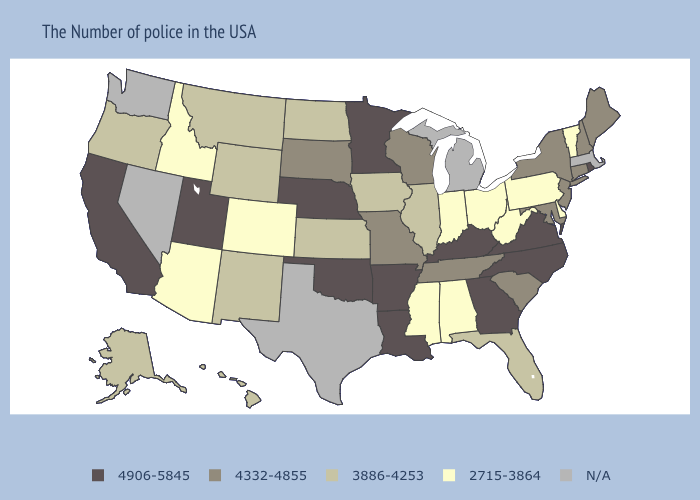Does the map have missing data?
Short answer required. Yes. Name the states that have a value in the range N/A?
Be succinct. Massachusetts, Michigan, Texas, Nevada, Washington. Does Oregon have the highest value in the USA?
Quick response, please. No. Which states have the highest value in the USA?
Answer briefly. Rhode Island, Virginia, North Carolina, Georgia, Kentucky, Louisiana, Arkansas, Minnesota, Nebraska, Oklahoma, Utah, California. Does the first symbol in the legend represent the smallest category?
Keep it brief. No. What is the value of South Carolina?
Give a very brief answer. 4332-4855. Name the states that have a value in the range 4332-4855?
Write a very short answer. Maine, New Hampshire, Connecticut, New York, New Jersey, Maryland, South Carolina, Tennessee, Wisconsin, Missouri, South Dakota. What is the lowest value in states that border Minnesota?
Concise answer only. 3886-4253. Does Vermont have the lowest value in the Northeast?
Be succinct. Yes. What is the value of Louisiana?
Keep it brief. 4906-5845. Which states have the lowest value in the West?
Give a very brief answer. Colorado, Arizona, Idaho. What is the lowest value in states that border Iowa?
Be succinct. 3886-4253. Among the states that border New Hampshire , does Maine have the lowest value?
Be succinct. No. Name the states that have a value in the range 3886-4253?
Concise answer only. Florida, Illinois, Iowa, Kansas, North Dakota, Wyoming, New Mexico, Montana, Oregon, Alaska, Hawaii. 